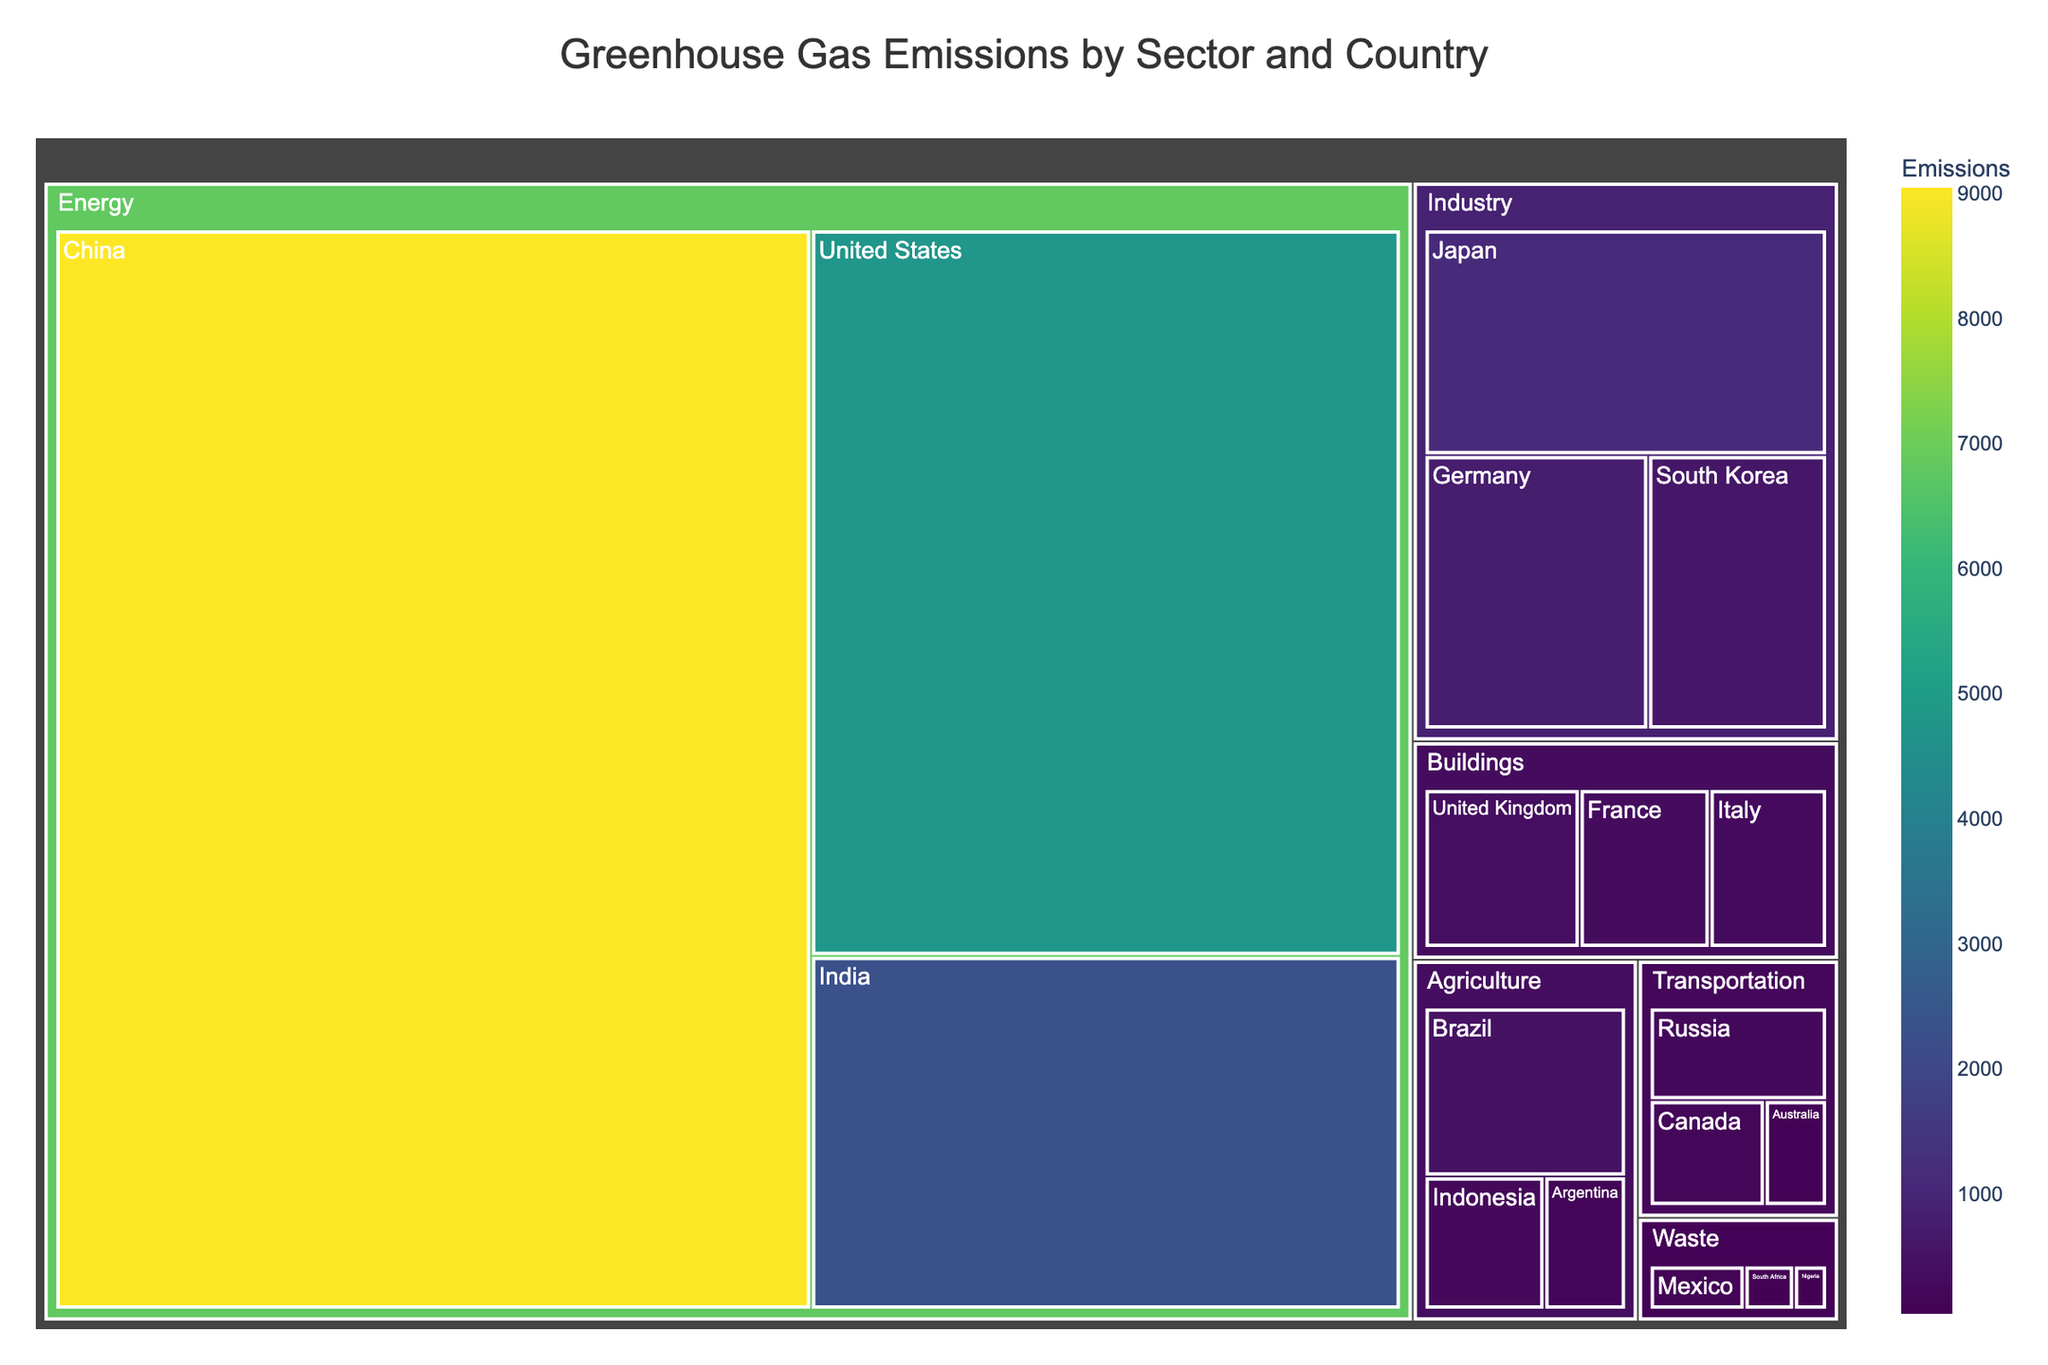What is the title of the Treemap? The title of any plot is usually displayed at the top of the figure. Here, the title is clearly shown on the Treemap.
Answer: Greenhouse Gas Emissions by Sector and Country Which sector has the highest greenhouse gas emissions? The sector with the largest area in the Treemap will have the highest emissions. The Energy sector occupies the largest space, indicating the highest emissions.
Answer: Energy How do the emissions from China compare to the emissions from the United States? Look for the sections representing China and the United States within the Energy sector and compare their sizes and values. China shows a value of 9040, whereas the United States shows a value of 4745.
Answer: China has higher emissions What is the color indicating in the Treemap? The legend and the color bar on the Treemap align with the emissions values. The shades from the color scheme (Viridis) represent the magnitude of emissions, with different colors for varying emissions levels.
Answer: Emissions values How many countries have emissions listed under the Waste sector? Similar-colored patches within the Waste sector and their labels can be counted to determine the number of countries. In this case, there are three countries: Mexico, South Africa, and Nigeria.
Answer: Three Which country has the lowest emissions in the Buildings sector? Within the Buildings sector, comparing the sizes or values of Italy, France, and the United Kingdom reveals that Italy has the smallest area with a value of 280.
Answer: Italy What is the sum of emissions from countries in the Agriculture sector? Adding the values for Brazil, Indonesia, and Argentina in the Agriculture sector: 470 + 220 + 150 = 840.
Answer: 840 Which country in the Industry sector has higher emissions, Germany or Japan? Comparing the values for Germany and Japan within the Industry sector shows Japan (1110) has higher emissions than Germany (750).
Answer: Japan What is the difference in emissions between the country with the highest emissions and the country with the lowest emissions? Identifying the values, China (9040) has the highest emissions, and Nigeria (40) has the lowest. The difference is 9040 - 40 = 9000.
Answer: 9000 What sector contributes the least to greenhouse gas emissions and which country within this sector has the lowest emission? The smallest area within the Treemap, indicating the least emissions, would be within Waste. Among the countries in Waste, Nigeria has the lowest emissions (40).
Answer: Waste, Nigeria 